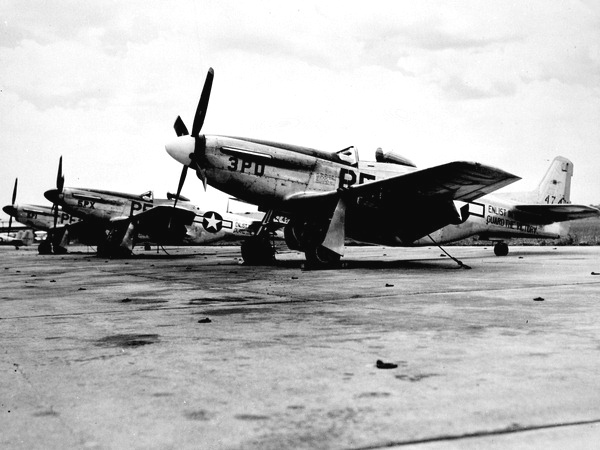What specific model of P-51 Mustang are we looking at? Without closer inspection or additional markers, it's challenging to definitively identify the precise model of these P-51 Mustangs. However, common variants used in World War II include the P-51B/C and the P-51D, the latter distinguished by its bubble canopy. The presence of the teardrop or bubble canopy allows experts to more easily discern the D model from earlier versions with the high-back and birdcage canopy. 